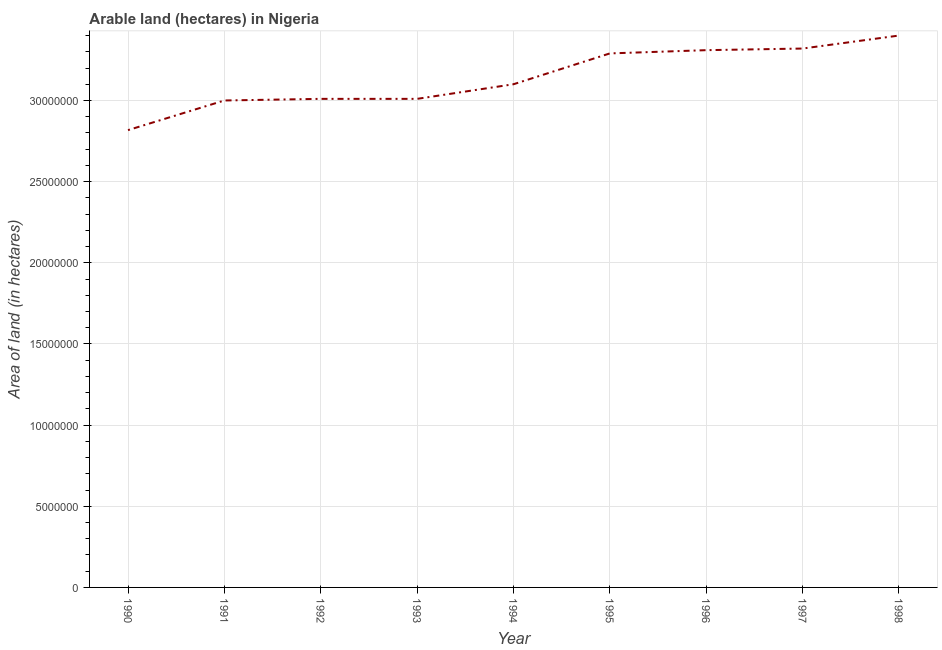What is the area of land in 1990?
Offer a very short reply. 2.82e+07. Across all years, what is the maximum area of land?
Offer a very short reply. 3.40e+07. Across all years, what is the minimum area of land?
Provide a succinct answer. 2.82e+07. In which year was the area of land maximum?
Ensure brevity in your answer.  1998. What is the sum of the area of land?
Make the answer very short. 2.83e+08. What is the difference between the area of land in 1992 and 1995?
Your answer should be very brief. -2.80e+06. What is the average area of land per year?
Keep it short and to the point. 3.14e+07. What is the median area of land?
Make the answer very short. 3.10e+07. In how many years, is the area of land greater than 2000000 hectares?
Provide a short and direct response. 9. What is the ratio of the area of land in 1992 to that in 1993?
Offer a terse response. 1. Is the area of land in 1994 less than that in 1998?
Ensure brevity in your answer.  Yes. Is the difference between the area of land in 1991 and 1994 greater than the difference between any two years?
Keep it short and to the point. No. What is the difference between the highest and the second highest area of land?
Your answer should be compact. 8.00e+05. What is the difference between the highest and the lowest area of land?
Your answer should be compact. 5.83e+06. Does the area of land monotonically increase over the years?
Offer a very short reply. No. How many lines are there?
Your response must be concise. 1. What is the title of the graph?
Your response must be concise. Arable land (hectares) in Nigeria. What is the label or title of the X-axis?
Offer a very short reply. Year. What is the label or title of the Y-axis?
Your response must be concise. Area of land (in hectares). What is the Area of land (in hectares) of 1990?
Provide a succinct answer. 2.82e+07. What is the Area of land (in hectares) of 1991?
Your answer should be compact. 3.00e+07. What is the Area of land (in hectares) in 1992?
Offer a very short reply. 3.01e+07. What is the Area of land (in hectares) in 1993?
Provide a succinct answer. 3.01e+07. What is the Area of land (in hectares) of 1994?
Your answer should be compact. 3.10e+07. What is the Area of land (in hectares) of 1995?
Make the answer very short. 3.29e+07. What is the Area of land (in hectares) in 1996?
Give a very brief answer. 3.31e+07. What is the Area of land (in hectares) in 1997?
Ensure brevity in your answer.  3.32e+07. What is the Area of land (in hectares) of 1998?
Make the answer very short. 3.40e+07. What is the difference between the Area of land (in hectares) in 1990 and 1991?
Give a very brief answer. -1.83e+06. What is the difference between the Area of land (in hectares) in 1990 and 1992?
Your answer should be very brief. -1.93e+06. What is the difference between the Area of land (in hectares) in 1990 and 1993?
Make the answer very short. -1.93e+06. What is the difference between the Area of land (in hectares) in 1990 and 1994?
Ensure brevity in your answer.  -2.83e+06. What is the difference between the Area of land (in hectares) in 1990 and 1995?
Make the answer very short. -4.73e+06. What is the difference between the Area of land (in hectares) in 1990 and 1996?
Ensure brevity in your answer.  -4.93e+06. What is the difference between the Area of land (in hectares) in 1990 and 1997?
Your answer should be compact. -5.03e+06. What is the difference between the Area of land (in hectares) in 1990 and 1998?
Keep it short and to the point. -5.83e+06. What is the difference between the Area of land (in hectares) in 1991 and 1992?
Ensure brevity in your answer.  -1.00e+05. What is the difference between the Area of land (in hectares) in 1991 and 1995?
Your response must be concise. -2.90e+06. What is the difference between the Area of land (in hectares) in 1991 and 1996?
Provide a short and direct response. -3.10e+06. What is the difference between the Area of land (in hectares) in 1991 and 1997?
Ensure brevity in your answer.  -3.20e+06. What is the difference between the Area of land (in hectares) in 1991 and 1998?
Ensure brevity in your answer.  -4.00e+06. What is the difference between the Area of land (in hectares) in 1992 and 1993?
Your response must be concise. 0. What is the difference between the Area of land (in hectares) in 1992 and 1994?
Give a very brief answer. -9.00e+05. What is the difference between the Area of land (in hectares) in 1992 and 1995?
Provide a succinct answer. -2.80e+06. What is the difference between the Area of land (in hectares) in 1992 and 1997?
Your answer should be compact. -3.10e+06. What is the difference between the Area of land (in hectares) in 1992 and 1998?
Provide a succinct answer. -3.90e+06. What is the difference between the Area of land (in hectares) in 1993 and 1994?
Offer a terse response. -9.00e+05. What is the difference between the Area of land (in hectares) in 1993 and 1995?
Make the answer very short. -2.80e+06. What is the difference between the Area of land (in hectares) in 1993 and 1996?
Give a very brief answer. -3.00e+06. What is the difference between the Area of land (in hectares) in 1993 and 1997?
Your answer should be very brief. -3.10e+06. What is the difference between the Area of land (in hectares) in 1993 and 1998?
Your answer should be very brief. -3.90e+06. What is the difference between the Area of land (in hectares) in 1994 and 1995?
Keep it short and to the point. -1.90e+06. What is the difference between the Area of land (in hectares) in 1994 and 1996?
Offer a very short reply. -2.10e+06. What is the difference between the Area of land (in hectares) in 1994 and 1997?
Your answer should be very brief. -2.20e+06. What is the difference between the Area of land (in hectares) in 1994 and 1998?
Make the answer very short. -3.00e+06. What is the difference between the Area of land (in hectares) in 1995 and 1996?
Ensure brevity in your answer.  -2.00e+05. What is the difference between the Area of land (in hectares) in 1995 and 1998?
Provide a succinct answer. -1.10e+06. What is the difference between the Area of land (in hectares) in 1996 and 1998?
Make the answer very short. -9.00e+05. What is the difference between the Area of land (in hectares) in 1997 and 1998?
Offer a very short reply. -8.00e+05. What is the ratio of the Area of land (in hectares) in 1990 to that in 1991?
Ensure brevity in your answer.  0.94. What is the ratio of the Area of land (in hectares) in 1990 to that in 1992?
Make the answer very short. 0.94. What is the ratio of the Area of land (in hectares) in 1990 to that in 1993?
Your answer should be compact. 0.94. What is the ratio of the Area of land (in hectares) in 1990 to that in 1994?
Provide a succinct answer. 0.91. What is the ratio of the Area of land (in hectares) in 1990 to that in 1995?
Ensure brevity in your answer.  0.86. What is the ratio of the Area of land (in hectares) in 1990 to that in 1996?
Offer a very short reply. 0.85. What is the ratio of the Area of land (in hectares) in 1990 to that in 1997?
Your answer should be very brief. 0.85. What is the ratio of the Area of land (in hectares) in 1990 to that in 1998?
Offer a very short reply. 0.83. What is the ratio of the Area of land (in hectares) in 1991 to that in 1992?
Give a very brief answer. 1. What is the ratio of the Area of land (in hectares) in 1991 to that in 1993?
Your answer should be compact. 1. What is the ratio of the Area of land (in hectares) in 1991 to that in 1994?
Offer a very short reply. 0.97. What is the ratio of the Area of land (in hectares) in 1991 to that in 1995?
Provide a succinct answer. 0.91. What is the ratio of the Area of land (in hectares) in 1991 to that in 1996?
Keep it short and to the point. 0.91. What is the ratio of the Area of land (in hectares) in 1991 to that in 1997?
Offer a terse response. 0.9. What is the ratio of the Area of land (in hectares) in 1991 to that in 1998?
Give a very brief answer. 0.88. What is the ratio of the Area of land (in hectares) in 1992 to that in 1993?
Provide a short and direct response. 1. What is the ratio of the Area of land (in hectares) in 1992 to that in 1995?
Provide a succinct answer. 0.92. What is the ratio of the Area of land (in hectares) in 1992 to that in 1996?
Provide a succinct answer. 0.91. What is the ratio of the Area of land (in hectares) in 1992 to that in 1997?
Make the answer very short. 0.91. What is the ratio of the Area of land (in hectares) in 1992 to that in 1998?
Provide a succinct answer. 0.89. What is the ratio of the Area of land (in hectares) in 1993 to that in 1995?
Ensure brevity in your answer.  0.92. What is the ratio of the Area of land (in hectares) in 1993 to that in 1996?
Offer a terse response. 0.91. What is the ratio of the Area of land (in hectares) in 1993 to that in 1997?
Provide a succinct answer. 0.91. What is the ratio of the Area of land (in hectares) in 1993 to that in 1998?
Your answer should be very brief. 0.89. What is the ratio of the Area of land (in hectares) in 1994 to that in 1995?
Your answer should be very brief. 0.94. What is the ratio of the Area of land (in hectares) in 1994 to that in 1996?
Provide a short and direct response. 0.94. What is the ratio of the Area of land (in hectares) in 1994 to that in 1997?
Offer a terse response. 0.93. What is the ratio of the Area of land (in hectares) in 1994 to that in 1998?
Your answer should be compact. 0.91. What is the ratio of the Area of land (in hectares) in 1995 to that in 1996?
Provide a short and direct response. 0.99. What is the ratio of the Area of land (in hectares) in 1995 to that in 1997?
Your answer should be very brief. 0.99. What is the ratio of the Area of land (in hectares) in 1996 to that in 1998?
Give a very brief answer. 0.97. 